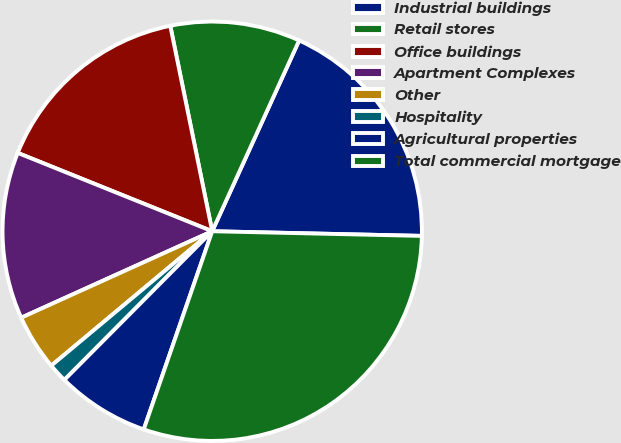Convert chart to OTSL. <chart><loc_0><loc_0><loc_500><loc_500><pie_chart><fcel>Industrial buildings<fcel>Retail stores<fcel>Office buildings<fcel>Apartment Complexes<fcel>Other<fcel>Hospitality<fcel>Agricultural properties<fcel>Total commercial mortgage<nl><fcel>18.55%<fcel>10.01%<fcel>15.7%<fcel>12.86%<fcel>4.31%<fcel>1.47%<fcel>7.16%<fcel>29.94%<nl></chart> 